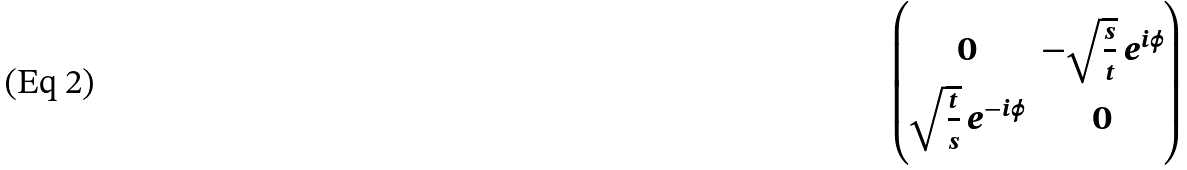Convert formula to latex. <formula><loc_0><loc_0><loc_500><loc_500>\begin{pmatrix} 0 & - \sqrt { \frac { s } { t } } \, e ^ { i \phi } \\ \sqrt { \frac { t } { s } } \, e ^ { - i \phi } & 0 \end{pmatrix}</formula> 